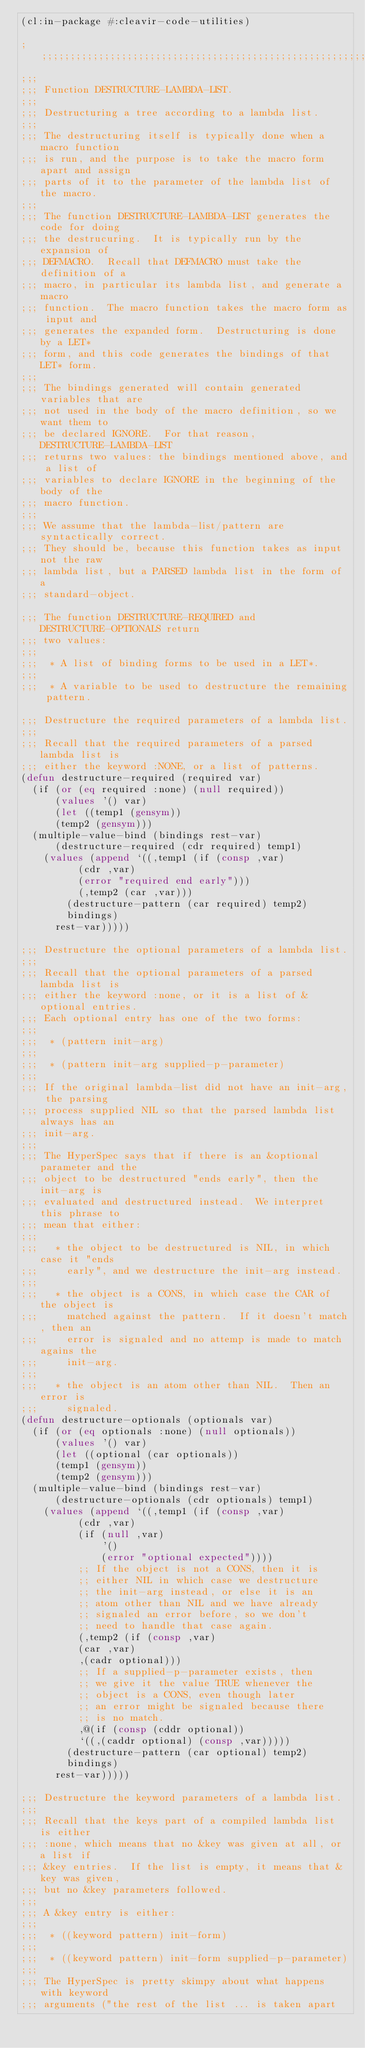Convert code to text. <code><loc_0><loc_0><loc_500><loc_500><_Lisp_>(cl:in-package #:cleavir-code-utilities)

;;;;;;;;;;;;;;;;;;;;;;;;;;;;;;;;;;;;;;;;;;;;;;;;;;;;;;;;;;;;;;;;;;;;;;
;;;
;;; Function DESTRUCTURE-LAMBDA-LIST.
;;;
;;; Destructuring a tree according to a lambda list.
;;;
;;; The destructuring itself is typically done when a macro function
;;; is run, and the purpose is to take the macro form apart and assign
;;; parts of it to the parameter of the lambda list of the macro.
;;;
;;; The function DESTRUCTURE-LAMBDA-LIST generates the code for doing
;;; the destrucuring.  It is typically run by the expansion of
;;; DEFMACRO.  Recall that DEFMACRO must take the definition of a
;;; macro, in particular its lambda list, and generate a macro
;;; function.  The macro function takes the macro form as input and
;;; generates the expanded form.  Destructuring is done by a LET*
;;; form, and this code generates the bindings of that LET* form.
;;;
;;; The bindings generated will contain generated variables that are
;;; not used in the body of the macro definition, so we want them to
;;; be declared IGNORE.  For that reason, DESTRUCTURE-LAMBDA-LIST
;;; returns two values: the bindings mentioned above, and a list of
;;; variables to declare IGNORE in the beginning of the body of the
;;; macro function.
;;;
;;; We assume that the lambda-list/pattern are syntactically correct.
;;; They should be, because this function takes as input not the raw
;;; lambda list, but a PARSED lambda list in the form of a
;;; standard-object.

;;; The function DESTRUCTURE-REQUIRED and DESTRUCTURE-OPTIONALS return
;;; two values:
;;;
;;;  * A list of binding forms to be used in a LET*.
;;;
;;;  * A variable to be used to destructure the remaining pattern.

;;; Destructure the required parameters of a lambda list.
;;;
;;; Recall that the required parameters of a parsed lambda list is
;;; either the keyword :NONE, or a list of patterns.
(defun destructure-required (required var)
  (if (or (eq required :none) (null required))
      (values '() var)
      (let ((temp1 (gensym))
	    (temp2 (gensym)))
	(multiple-value-bind (bindings rest-var)
	    (destructure-required (cdr required) temp1)
	  (values (append `((,temp1 (if (consp ,var)
					(cdr ,var)
					(error "required end early")))
			    (,temp2 (car ,var)))
			  (destructure-pattern (car required) temp2)
			  bindings)
		  rest-var)))))

;;; Destructure the optional parameters of a lambda list.
;;;
;;; Recall that the optional parameters of a parsed lambda list is
;;; either the keyword :none, or it is a list of &optional entries.
;;; Each optional entry has one of the two forms:
;;;
;;;  * (pattern init-arg)
;;;
;;;  * (pattern init-arg supplied-p-parameter)
;;;
;;; If the original lambda-list did not have an init-arg, the parsing
;;; process supplied NIL so that the parsed lambda list always has an
;;; init-arg.
;;;
;;; The HyperSpec says that if there is an &optional parameter and the
;;; object to be destructured "ends early", then the init-arg is
;;; evaluated and destructured instead.  We interpret this phrase to
;;; mean that either:
;;;
;;;   * the object to be destructured is NIL, in which case it "ends
;;;     early", and we destructure the init-arg instead.
;;;
;;;   * the object is a CONS, in which case the CAR of the object is
;;;     matched against the pattern.  If it doesn't match, then an
;;;     error is signaled and no attemp is made to match agains the
;;;     init-arg.
;;;
;;;   * the object is an atom other than NIL.  Then an error is
;;;     signaled.
(defun destructure-optionals (optionals var)
  (if (or (eq optionals :none) (null optionals))
      (values '() var)
      (let ((optional (car optionals))
	    (temp1 (gensym))
	    (temp2 (gensym)))
	(multiple-value-bind (bindings rest-var)
	    (destructure-optionals (cdr optionals) temp1)
	  (values (append `((,temp1 (if (consp ,var)
					(cdr ,var)
					(if (null ,var)
					    '()
					    (error "optional expected"))))
			    ;; If the object is not a CONS, then it is
			    ;; either NIL in which case we destructure
			    ;; the init-arg instead, or else it is an
			    ;; atom other than NIL and we have already
			    ;; signaled an error before, so we don't
			    ;; need to handle that case again.
			    (,temp2 (if (consp ,var)
					(car ,var)
					,(cadr optional)))
			    ;; If a supplied-p-parameter exists, then
			    ;; we give it the value TRUE whenever the
			    ;; object is a CONS, even though later
			    ;; an error might be signaled because there
			    ;; is no match.
			    ,@(if (consp (cddr optional))
				  `((,(caddr optional) (consp ,var)))))
			  (destructure-pattern (car optional) temp2)
			  bindings)
		  rest-var)))))

;;; Destructure the keyword parameters of a lambda list.
;;;
;;; Recall that the keys part of a compiled lambda list is either
;;; :none, which means that no &key was given at all, or a list if
;;; &key entries.  If the list is empty, it means that &key was given,
;;; but no &key parameters followed.
;;;
;;; A &key entry is either:
;;;
;;;  * ((keyword pattern) init-form)
;;;
;;;  * ((keyword pattern) init-form supplied-p-parameter)
;;;
;;; The HyperSpec is pretty skimpy about what happens with keyword
;;; arguments ("the rest of the list ... is taken apart</code> 